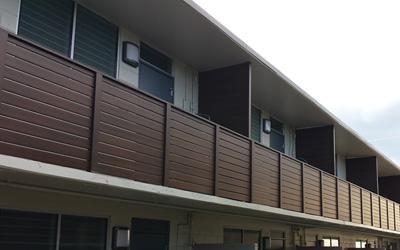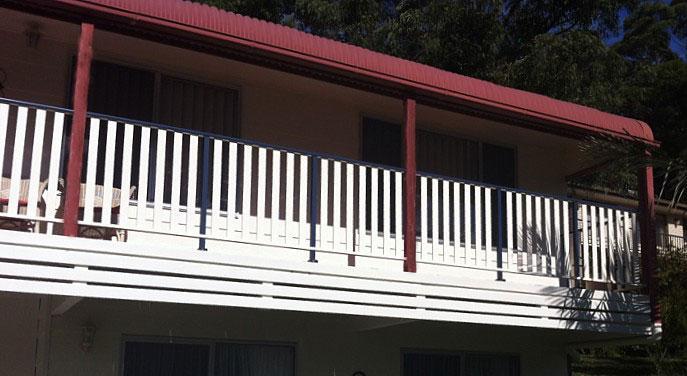The first image is the image on the left, the second image is the image on the right. Assess this claim about the two images: "There are are least three colored poles in between a white balcony fence.". Correct or not? Answer yes or no. Yes. The first image is the image on the left, the second image is the image on the right. Given the left and right images, does the statement "The balcony in the left image has close-together horizontal boards for rails, and the balcony on the right has vertical white bars for rails." hold true? Answer yes or no. Yes. 